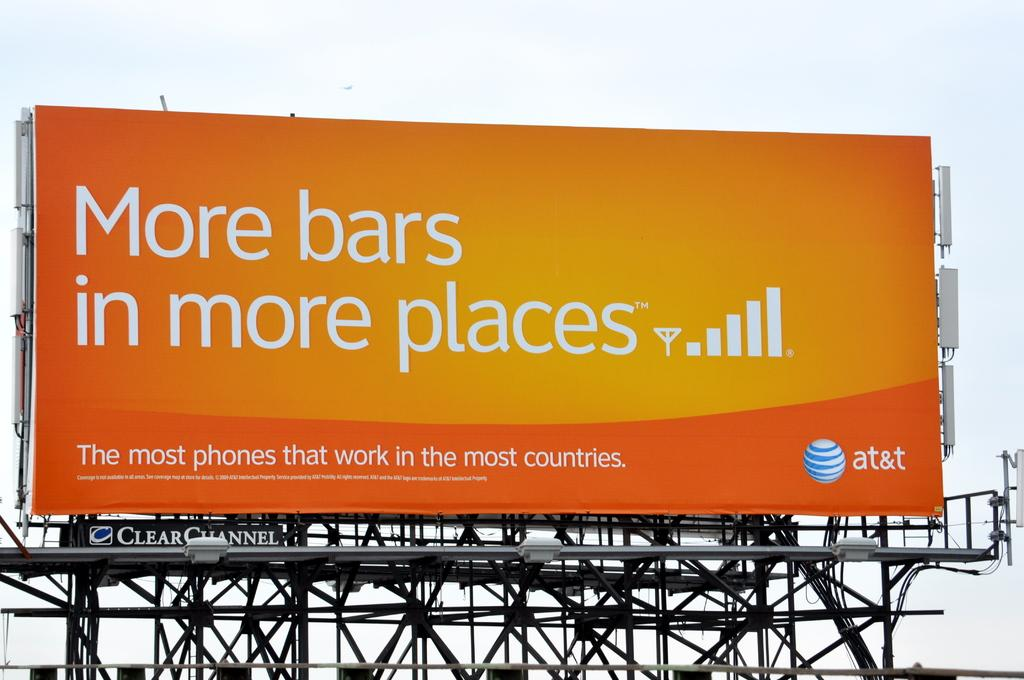<image>
Render a clear and concise summary of the photo. An orange and yellow billboard advertises cell service from AT&T. 